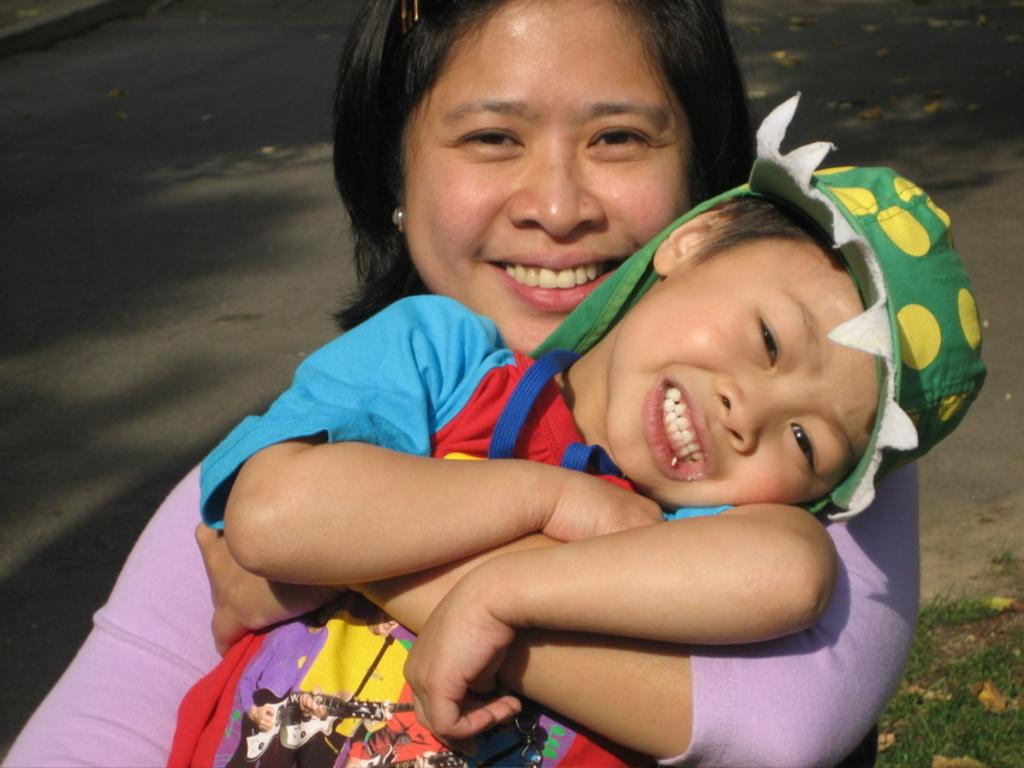Who is present in the image? There is a kid and a woman in the image. What can be seen in the background of the image? There is a road visible in the background of the image. What story is the kid telling the woman in the image? There is no indication in the image that the kid is telling a story to the woman. 